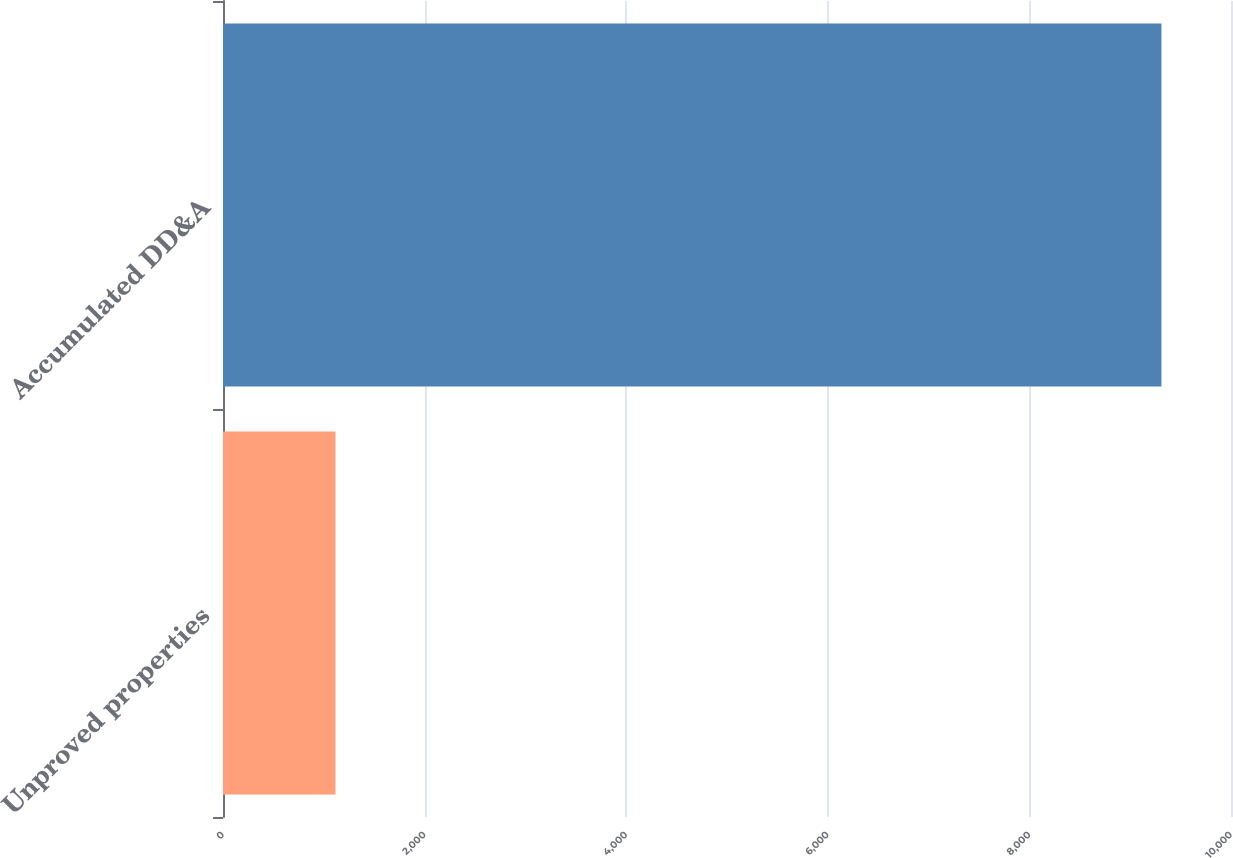Convert chart to OTSL. <chart><loc_0><loc_0><loc_500><loc_500><bar_chart><fcel>Unproved properties<fcel>Accumulated DD&A<nl><fcel>1116<fcel>9310<nl></chart> 